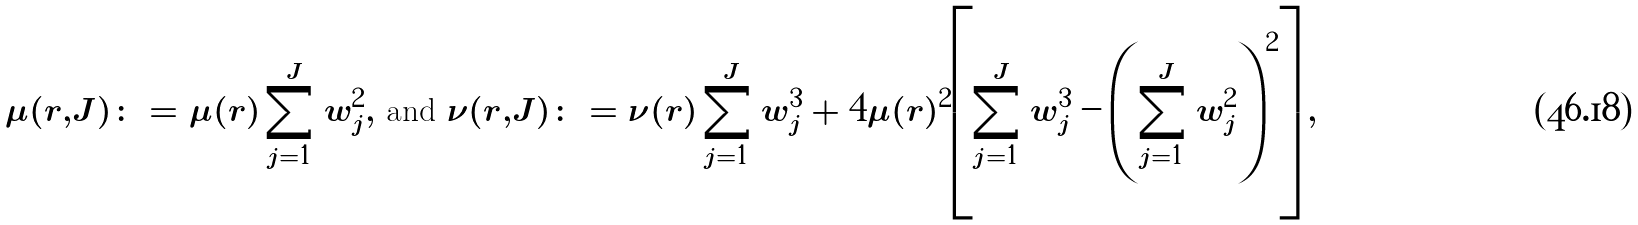Convert formula to latex. <formula><loc_0><loc_0><loc_500><loc_500>\mu ( r , J ) \colon = \mu ( r ) \, \sum _ { j = 1 } ^ { J } w _ { j } ^ { 2 } , \text { and } \nu ( r , J ) \colon = \nu ( r ) \, \sum _ { j = 1 } ^ { J } w _ { j } ^ { 3 } + 4 \mu ( r ) ^ { 2 } \left [ \sum _ { j = 1 } ^ { J } w _ { j } ^ { 3 } - \left ( \sum _ { j = 1 } ^ { J } w _ { j } ^ { 2 } \right ) ^ { 2 } \right ] ,</formula> 